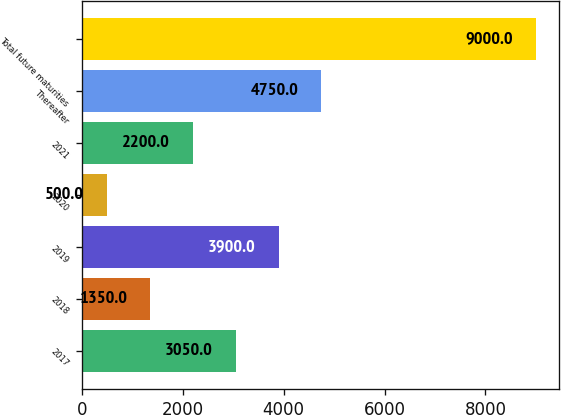Convert chart to OTSL. <chart><loc_0><loc_0><loc_500><loc_500><bar_chart><fcel>2017<fcel>2018<fcel>2019<fcel>2020<fcel>2021<fcel>Thereafter<fcel>Total future maturities<nl><fcel>3050<fcel>1350<fcel>3900<fcel>500<fcel>2200<fcel>4750<fcel>9000<nl></chart> 